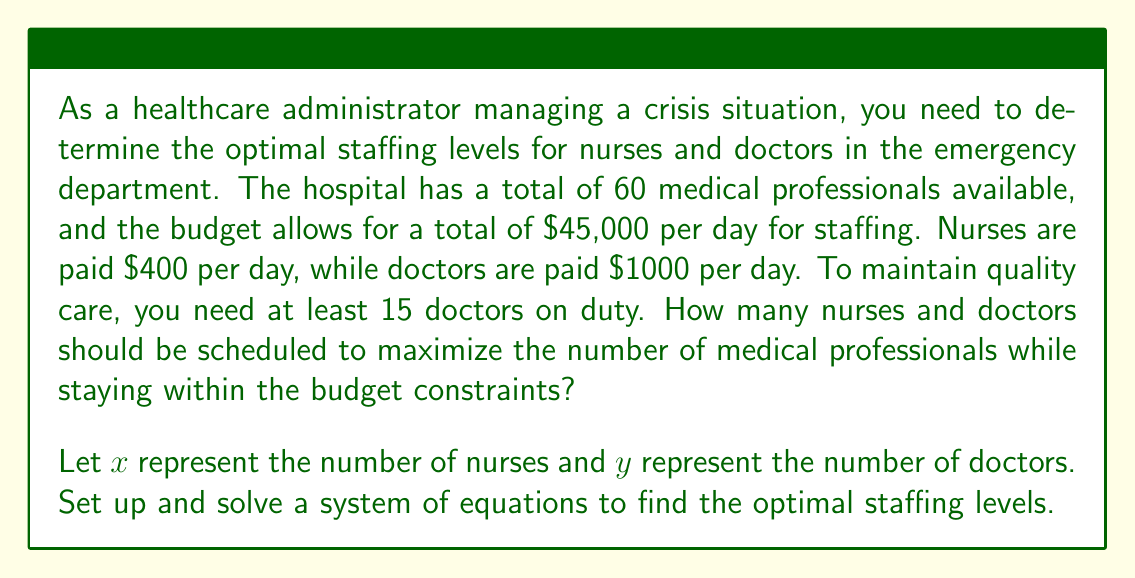Show me your answer to this math problem. To solve this problem, we need to set up a system of equations based on the given constraints and then solve it. Let's break it down step by step:

1. Set up the equations:

   a. Total number of medical professionals:
      $$x + y = 60$$ (Equation 1)

   b. Budget constraint:
      $$400x + 1000y = 45000$$ (Equation 2)

   c. Minimum number of doctors:
      $$y \geq 15$$

2. Solve the system of equations:

   From Equation 1: $x = 60 - y$

   Substitute this into Equation 2:
   $$400(60 - y) + 1000y = 45000$$
   $$24000 - 400y + 1000y = 45000$$
   $$24000 + 600y = 45000$$
   $$600y = 21000$$
   $$y = 35$$

   Now substitute $y = 35$ back into Equation 1:
   $$x + 35 = 60$$
   $$x = 25$$

3. Check the minimum doctor constraint:
   $y = 35$, which is greater than the minimum requirement of 15 doctors.

4. Verify the budget constraint:
   $$400(25) + 1000(35) = 10000 + 35000 = 45000$$

Therefore, the optimal staffing levels are 25 nurses and 35 doctors. This solution maximizes the number of medical professionals (60 total) while staying within the budget constraint and meeting the minimum doctor requirement.
Answer: The optimal staffing levels are 25 nurses and 35 doctors. 